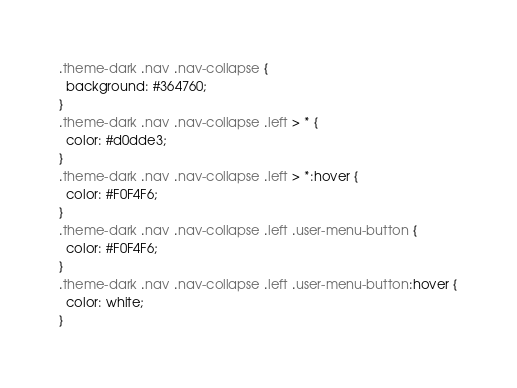Convert code to text. <code><loc_0><loc_0><loc_500><loc_500><_CSS_>.theme-dark .nav .nav-collapse {
  background: #364760;
}
.theme-dark .nav .nav-collapse .left > * {
  color: #d0dde3;
}
.theme-dark .nav .nav-collapse .left > *:hover {
  color: #F0F4F6;
}
.theme-dark .nav .nav-collapse .left .user-menu-button {
  color: #F0F4F6;
}
.theme-dark .nav .nav-collapse .left .user-menu-button:hover {
  color: white;
}
</code> 